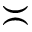<formula> <loc_0><loc_0><loc_500><loc_500>\asymp</formula> 